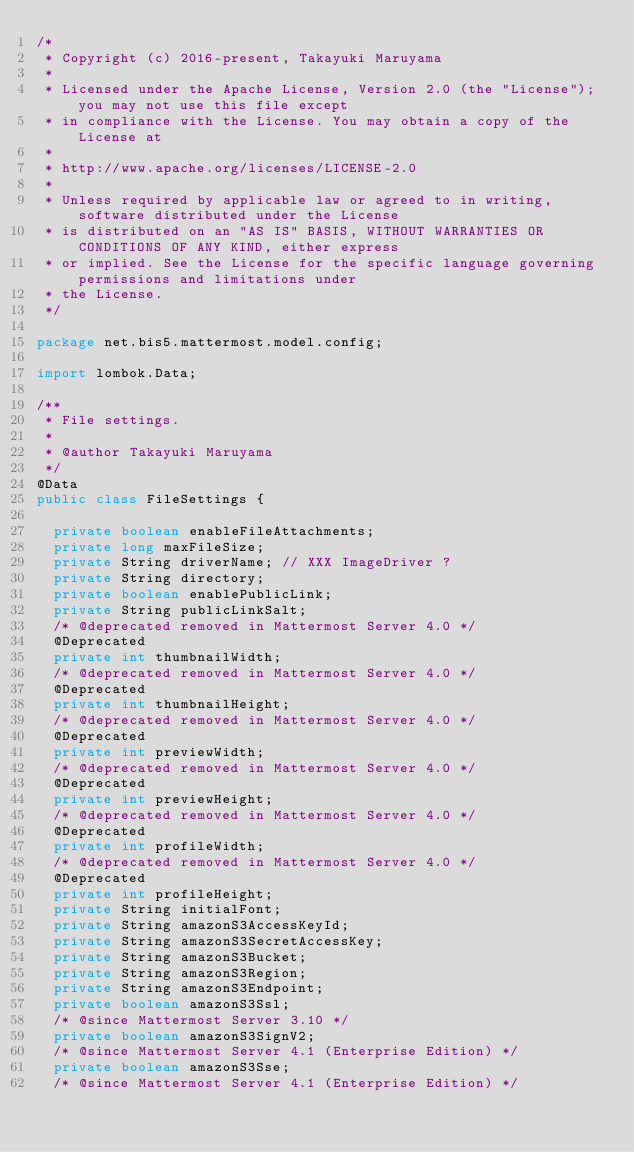<code> <loc_0><loc_0><loc_500><loc_500><_Java_>/*
 * Copyright (c) 2016-present, Takayuki Maruyama
 *
 * Licensed under the Apache License, Version 2.0 (the "License"); you may not use this file except
 * in compliance with the License. You may obtain a copy of the License at
 * 
 * http://www.apache.org/licenses/LICENSE-2.0
 * 
 * Unless required by applicable law or agreed to in writing, software distributed under the License
 * is distributed on an "AS IS" BASIS, WITHOUT WARRANTIES OR CONDITIONS OF ANY KIND, either express
 * or implied. See the License for the specific language governing permissions and limitations under
 * the License.
 */

package net.bis5.mattermost.model.config;

import lombok.Data;

/**
 * File settings.
 * 
 * @author Takayuki Maruyama
 */
@Data
public class FileSettings {

  private boolean enableFileAttachments;
  private long maxFileSize;
  private String driverName; // XXX ImageDriver ?
  private String directory;
  private boolean enablePublicLink;
  private String publicLinkSalt;
  /* @deprecated removed in Mattermost Server 4.0 */
  @Deprecated
  private int thumbnailWidth;
  /* @deprecated removed in Mattermost Server 4.0 */
  @Deprecated
  private int thumbnailHeight;
  /* @deprecated removed in Mattermost Server 4.0 */
  @Deprecated
  private int previewWidth;
  /* @deprecated removed in Mattermost Server 4.0 */
  @Deprecated
  private int previewHeight;
  /* @deprecated removed in Mattermost Server 4.0 */
  @Deprecated
  private int profileWidth;
  /* @deprecated removed in Mattermost Server 4.0 */
  @Deprecated
  private int profileHeight;
  private String initialFont;
  private String amazonS3AccessKeyId;
  private String amazonS3SecretAccessKey;
  private String amazonS3Bucket;
  private String amazonS3Region;
  private String amazonS3Endpoint;
  private boolean amazonS3Ssl;
  /* @since Mattermost Server 3.10 */
  private boolean amazonS3SignV2;
  /* @since Mattermost Server 4.1 (Enterprise Edition) */
  private boolean amazonS3Sse;
  /* @since Mattermost Server 4.1 (Enterprise Edition) */</code> 